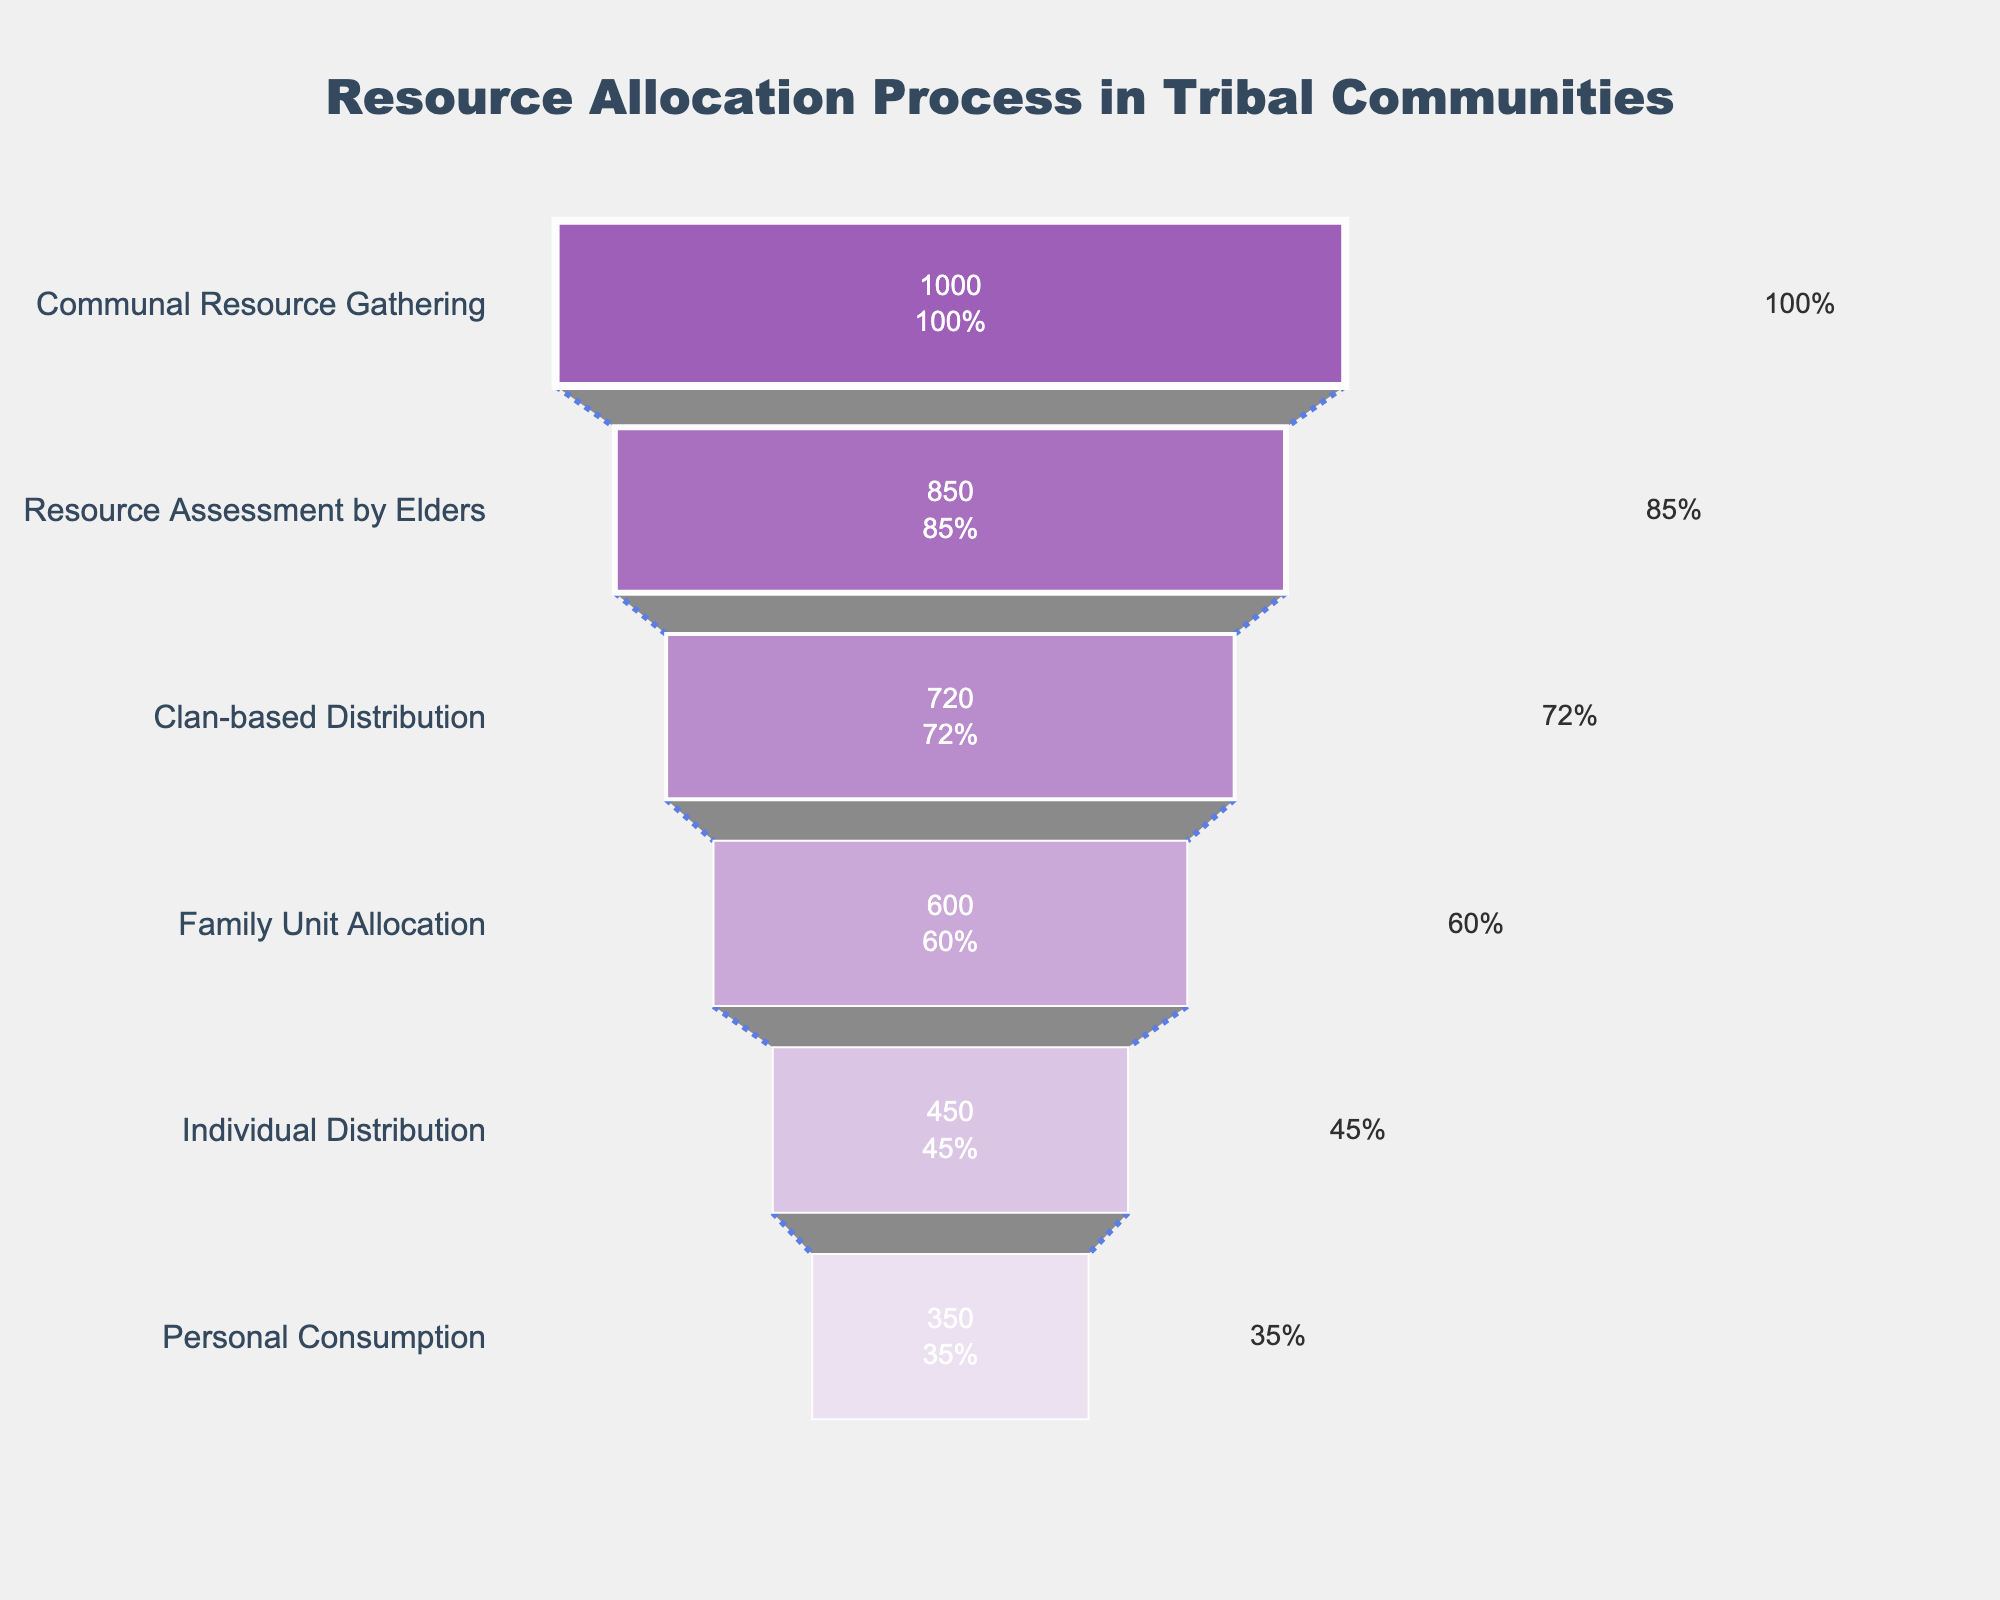What is the title of the funnel chart? The title of the funnel chart is located at the top of the figure. It is typically in larger font and stands out from the rest of the text.
Answer: Resource Allocation Process in Tribal Communities What percentage of participants reach the stage of Individual Distribution? To find the percentage at the stage of Individual Distribution, look at the labels inside the funnel at the relevant stage. It shows both the number of participants and the percentage.
Answer: 45% How many participants are lost between the stages of Family Unit Allocation and Individual Distribution? Subtract the number of participants at Individual Distribution (450) from the number at Family Unit Allocation (600).
Answer: 150 By what percentage does the number of participants decrease from Communal Resource Gathering to Personal Consumption? Find the percentage difference by subtracting the percentage at Personal Consumption (35%) from that at Communal Resource Gathering (100%).
Answer: 65% Which stage experiences the greatest drop in the number of participants? Calculate the drop in participants between consecutive stages, and identify the stage with the largest decrease. The largest drop is from Family Unit Allocation (600) to Individual Distribution (450).
Answer: Family Unit Allocation to Individual Distribution At which stage do elders assess the resources? Match the stage text with the keyword "elders."
Answer: Resource Assessment by Elders What is the color of the segment representing Resource Assessment by Elders? The color of each segment can be observed directly in the figure. The segment for Resource Assessment by Elders has the second distinct color from the top.
Answer: A light purple shade How does the percentage of participants change from Clan-based Distribution to Family Unit Allocation? Subtract the percentage at Family Unit Allocation (60%) from the percentage at Clan-based Distribution (72%).
Answer: 12% Which stage has the least number of participants? Identify the stage with the smallest numerical value for participants.
Answer: Personal Consumption Describe the trend in the number of participants across all stages. Observe the general direction of the participant numbers from the top to the bottom of the funnel. The number consistently decreases from one stage to the next, reflecting a narrowing funnel.
Answer: Decreasing trend 